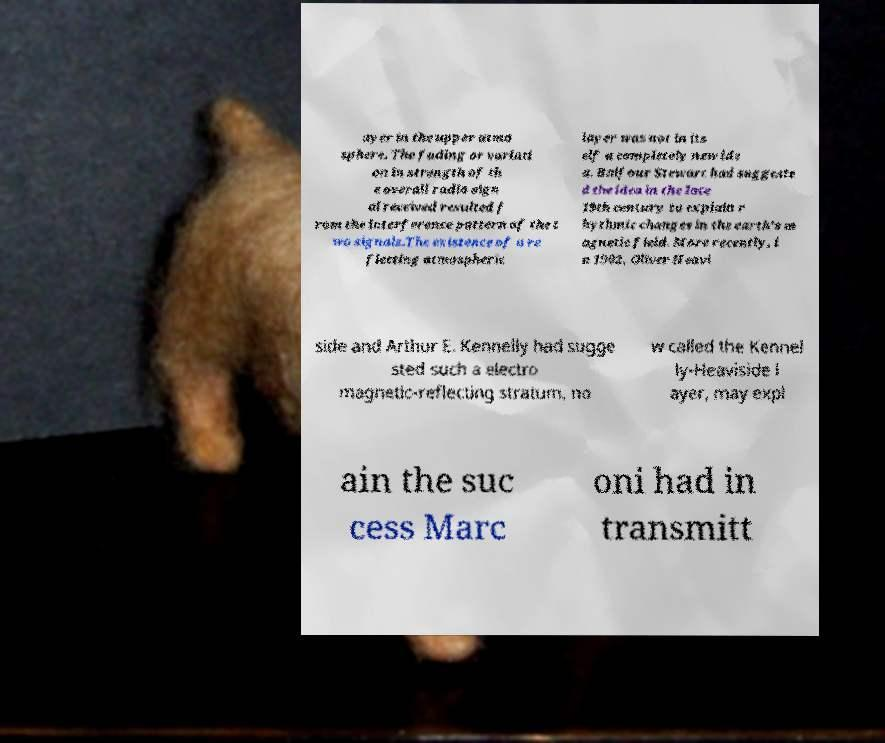Can you accurately transcribe the text from the provided image for me? ayer in the upper atmo sphere. The fading or variati on in strength of th e overall radio sign al received resulted f rom the interference pattern of the t wo signals.The existence of a re flecting atmospheric layer was not in its elf a completely new ide a. Balfour Stewart had suggeste d the idea in the late 19th century to explain r hythmic changes in the earth’s m agnetic field. More recently, i n 1902, Oliver Heavi side and Arthur E. Kennelly had sugge sted such a electro magnetic-reflecting stratum, no w called the Kennel ly-Heaviside l ayer, may expl ain the suc cess Marc oni had in transmitt 